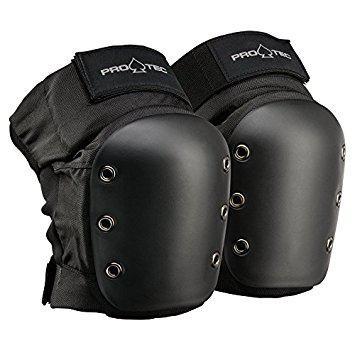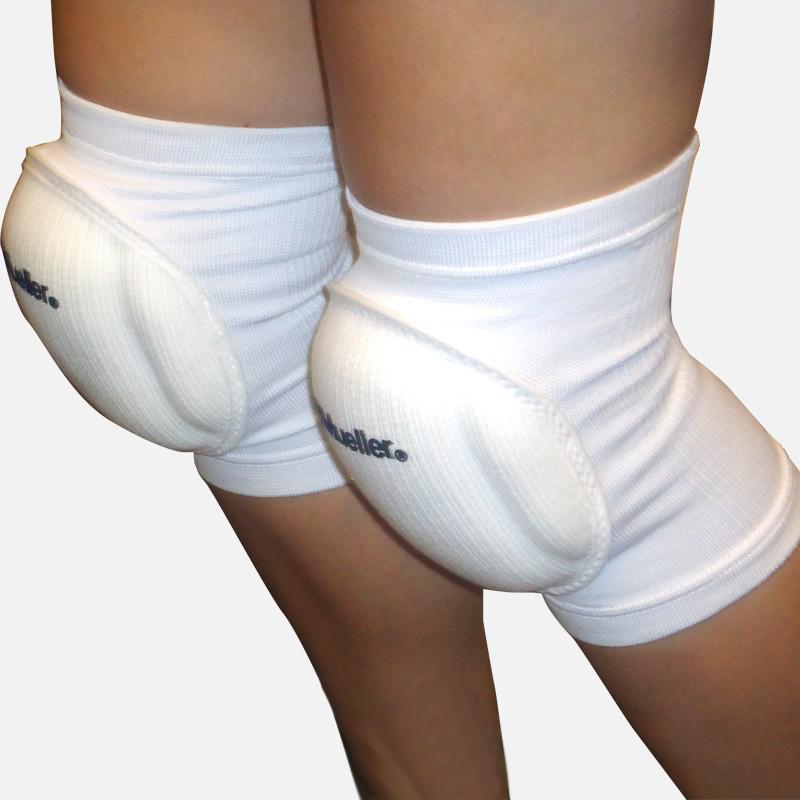The first image is the image on the left, the second image is the image on the right. For the images displayed, is the sentence "There are four legs and four knee pads." factually correct? Answer yes or no. No. The first image is the image on the left, the second image is the image on the right. Considering the images on both sides, is "Each image shows one pair of legs wearing a pair of knee pads." valid? Answer yes or no. No. 